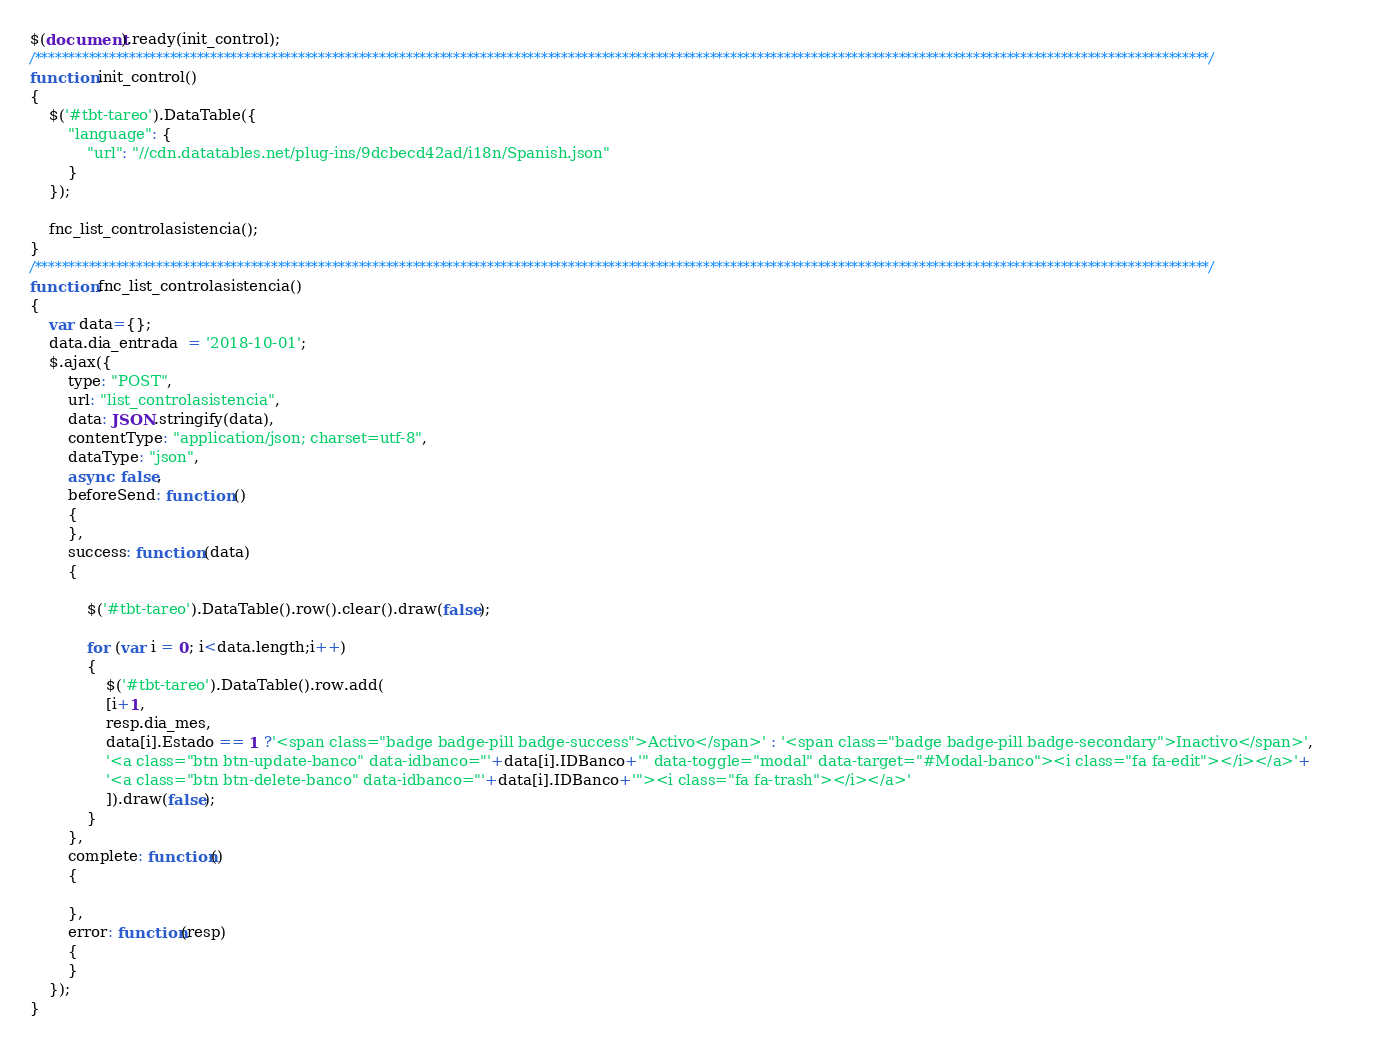<code> <loc_0><loc_0><loc_500><loc_500><_JavaScript_>$(document).ready(init_control);
/******************************************************************************************************************************************************************************/
function init_control()
{
    $('#tbt-tareo').DataTable({
        "language": {
            "url": "//cdn.datatables.net/plug-ins/9dcbecd42ad/i18n/Spanish.json"
        }
    });

    fnc_list_controlasistencia();
}
/******************************************************************************************************************************************************************************/
function fnc_list_controlasistencia()
{
    var data={};
    data.dia_entrada  = '2018-10-01';
    $.ajax({
        type: "POST",
        url: "list_controlasistencia",
        data: JSON.stringify(data),
        contentType: "application/json; charset=utf-8",
        dataType: "json",
        async: false,
        beforeSend: function () 
        {
        },
        success: function (data)
        {
            
            $('#tbt-tareo').DataTable().row().clear().draw(false);

            for (var i = 0; i<data.length;i++) 
            {
                $('#tbt-tareo').DataTable().row.add(
                [i+1,
                resp.dia_mes,
                data[i].Estado == 1 ?'<span class="badge badge-pill badge-success">Activo</span>' : '<span class="badge badge-pill badge-secondary">Inactivo</span>',
                '<a class="btn btn-update-banco" data-idbanco="'+data[i].IDBanco+'" data-toggle="modal" data-target="#Modal-banco"><i class="fa fa-edit"></i></a>'+
                '<a class="btn btn-delete-banco" data-idbanco="'+data[i].IDBanco+'"><i class="fa fa-trash"></i></a>'
                ]).draw(false);
            }     
        },
        complete: function()
        {
            
        },
        error: function(resp)
        {
        }
    });
} </code> 